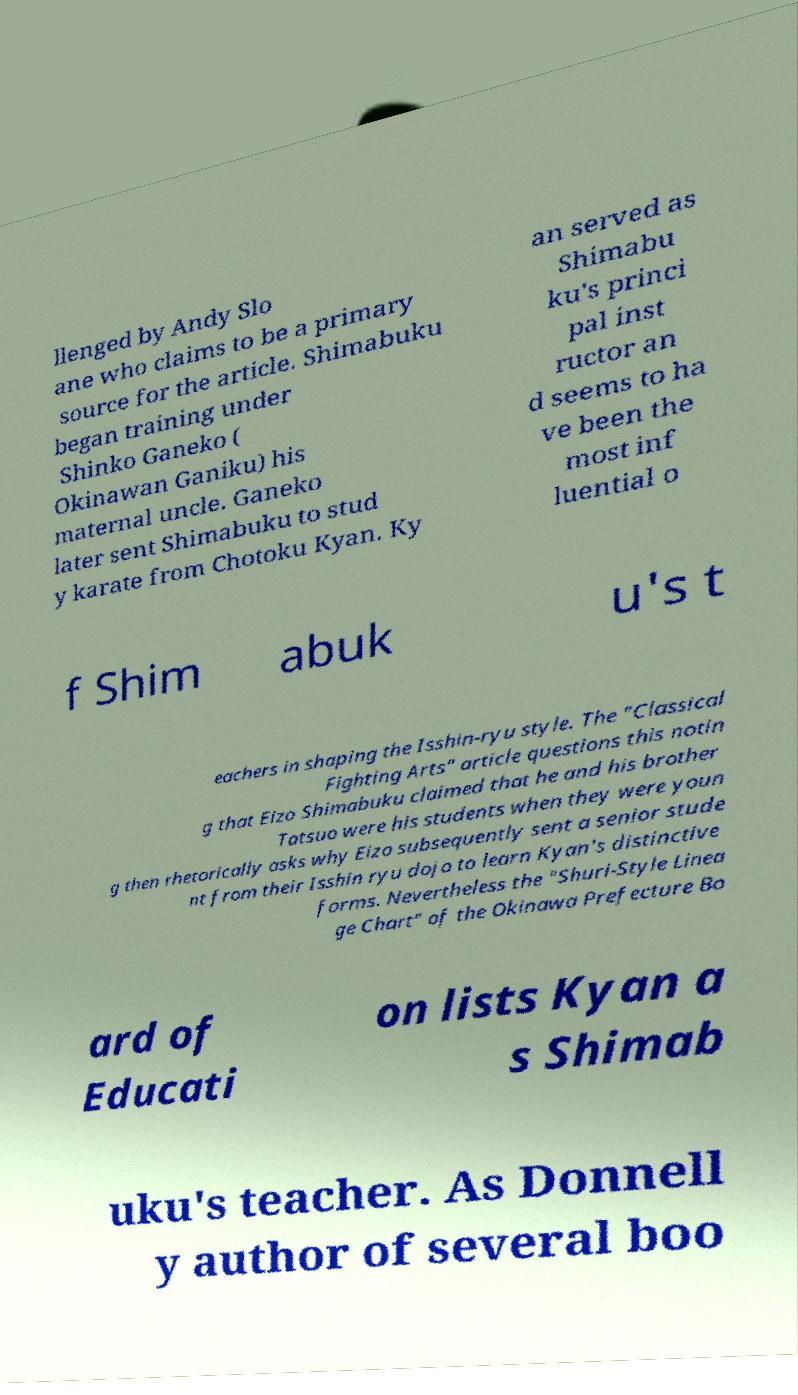There's text embedded in this image that I need extracted. Can you transcribe it verbatim? llenged by Andy Slo ane who claims to be a primary source for the article. Shimabuku began training under Shinko Ganeko ( Okinawan Ganiku) his maternal uncle. Ganeko later sent Shimabuku to stud y karate from Chotoku Kyan. Ky an served as Shimabu ku's princi pal inst ructor an d seems to ha ve been the most inf luential o f Shim abuk u's t eachers in shaping the Isshin-ryu style. The "Classical Fighting Arts" article questions this notin g that Eizo Shimabuku claimed that he and his brother Tatsuo were his students when they were youn g then rhetorically asks why Eizo subsequently sent a senior stude nt from their Isshin ryu dojo to learn Kyan's distinctive forms. Nevertheless the "Shuri-Style Linea ge Chart" of the Okinawa Prefecture Bo ard of Educati on lists Kyan a s Shimab uku's teacher. As Donnell y author of several boo 